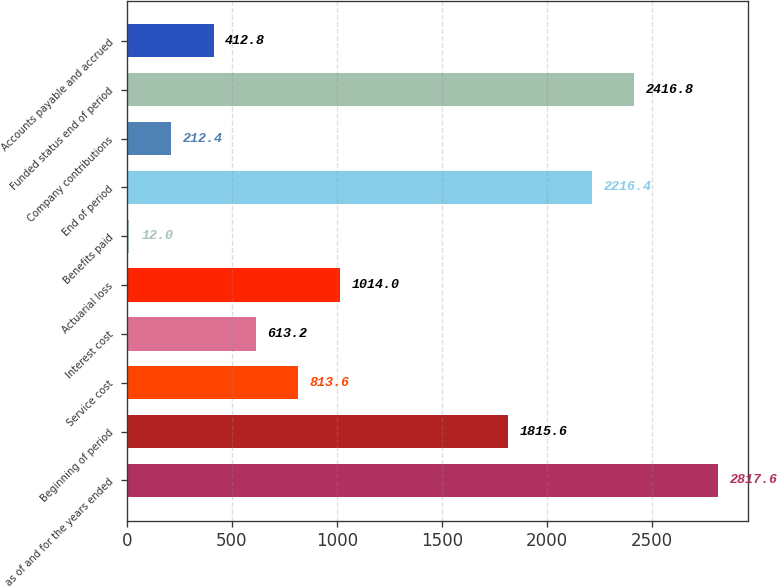Convert chart to OTSL. <chart><loc_0><loc_0><loc_500><loc_500><bar_chart><fcel>as of and for the years ended<fcel>Beginning of period<fcel>Service cost<fcel>Interest cost<fcel>Actuarial loss<fcel>Benefits paid<fcel>End of period<fcel>Company contributions<fcel>Funded status end of period<fcel>Accounts payable and accrued<nl><fcel>2817.6<fcel>1815.6<fcel>813.6<fcel>613.2<fcel>1014<fcel>12<fcel>2216.4<fcel>212.4<fcel>2416.8<fcel>412.8<nl></chart> 